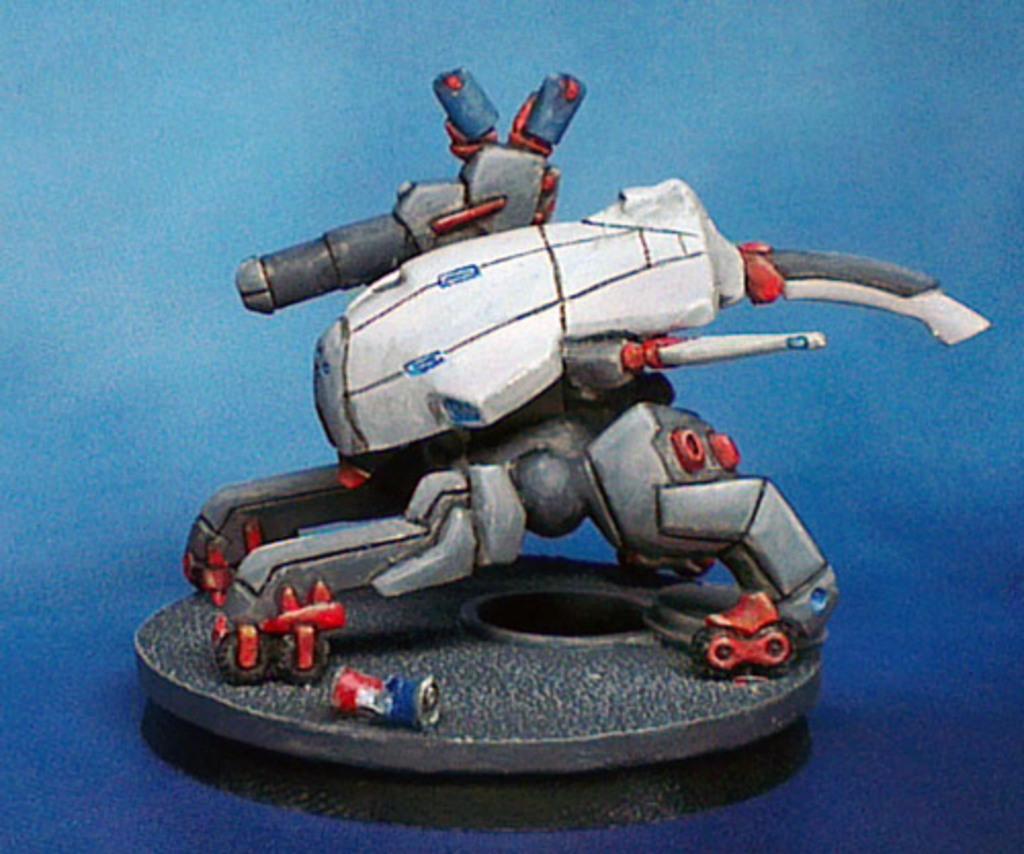Describe this image in one or two sentences. In this image we can see an animated picture of a toy. 